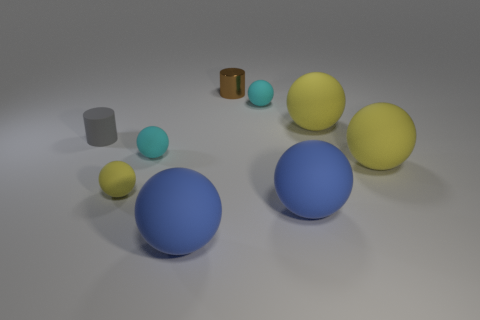How many yellow balls must be subtracted to get 1 yellow balls? 2 Subtract all purple blocks. How many yellow balls are left? 3 Subtract all blue spheres. How many spheres are left? 5 Subtract all large yellow rubber spheres. How many spheres are left? 5 Subtract all blue spheres. Subtract all green cubes. How many spheres are left? 5 Add 1 big objects. How many objects exist? 10 Subtract all balls. How many objects are left? 2 Subtract 0 cyan cylinders. How many objects are left? 9 Subtract all red cylinders. Subtract all shiny cylinders. How many objects are left? 8 Add 6 metallic things. How many metallic things are left? 7 